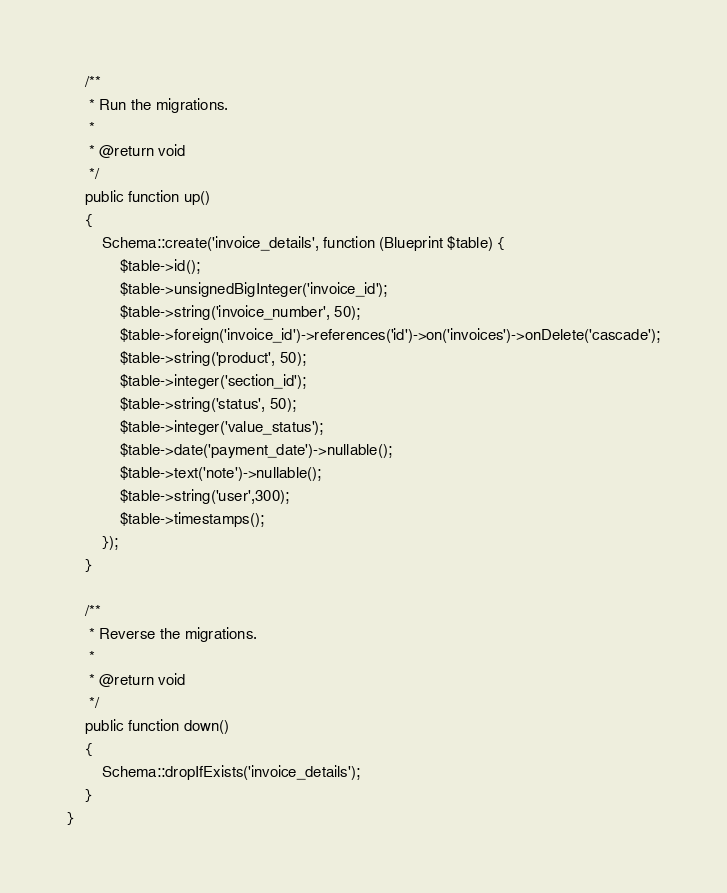Convert code to text. <code><loc_0><loc_0><loc_500><loc_500><_PHP_>    /**
     * Run the migrations.
     *
     * @return void
     */
    public function up()
    {
        Schema::create('invoice_details', function (Blueprint $table) {
            $table->id();
            $table->unsignedBigInteger('invoice_id');
            $table->string('invoice_number', 50);
            $table->foreign('invoice_id')->references('id')->on('invoices')->onDelete('cascade');
            $table->string('product', 50);
            $table->integer('section_id');
            $table->string('status', 50);
            $table->integer('value_status');
            $table->date('payment_date')->nullable();
            $table->text('note')->nullable();
            $table->string('user',300);
            $table->timestamps();
        });
    }

    /**
     * Reverse the migrations.
     *
     * @return void
     */
    public function down()
    {
        Schema::dropIfExists('invoice_details');
    }
}
</code> 